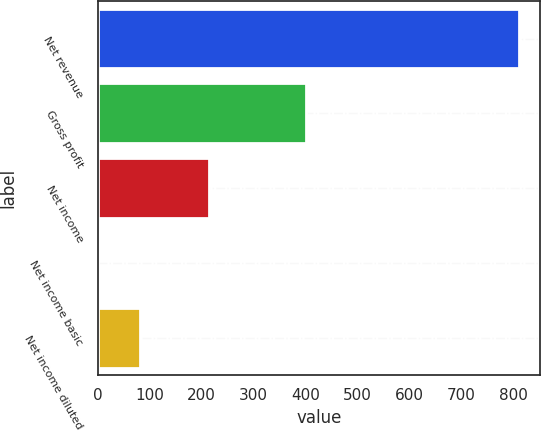<chart> <loc_0><loc_0><loc_500><loc_500><bar_chart><fcel>Net revenue<fcel>Gross profit<fcel>Net income<fcel>Net income basic<fcel>Net income diluted<nl><fcel>810.4<fcel>400.2<fcel>214<fcel>1.23<fcel>82.15<nl></chart> 